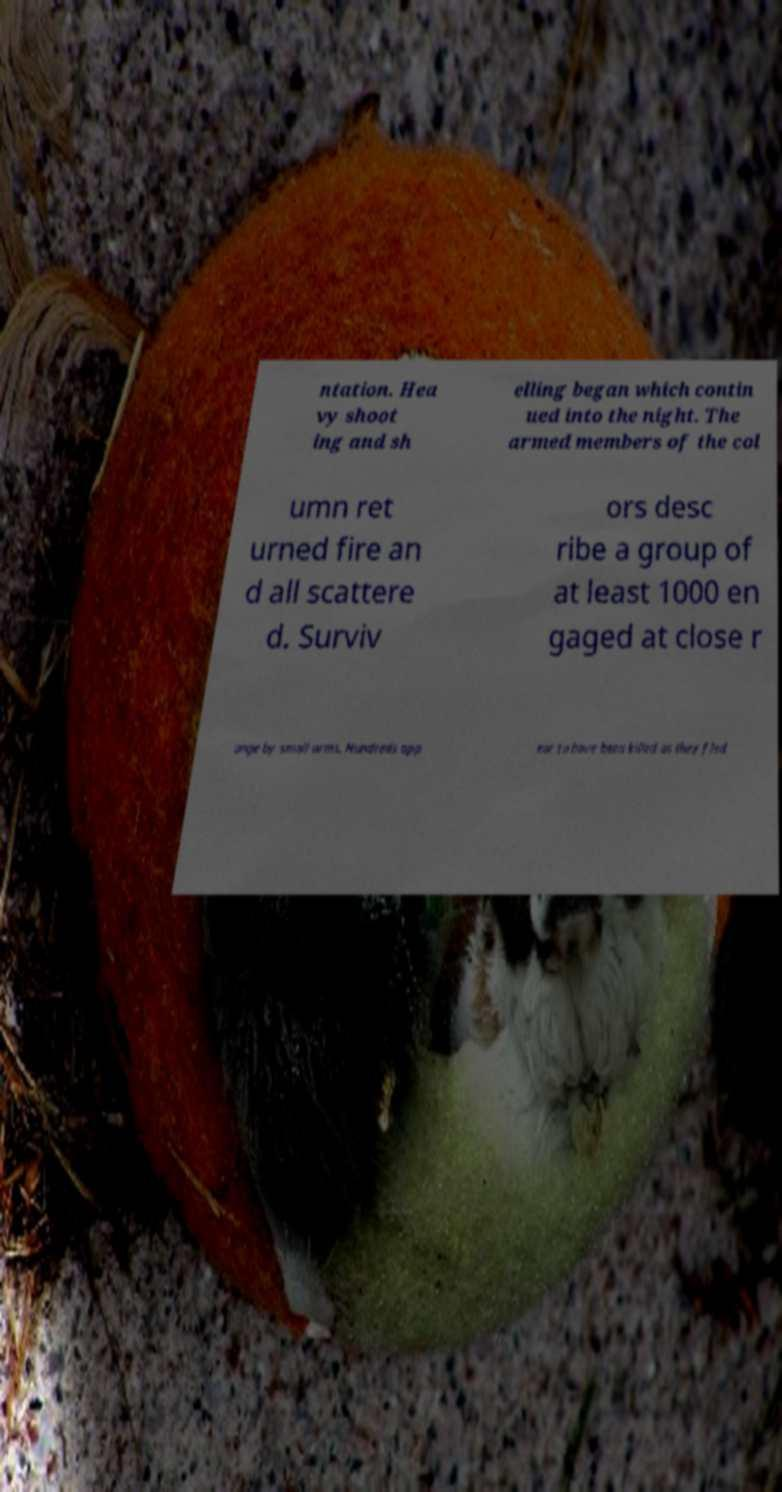For documentation purposes, I need the text within this image transcribed. Could you provide that? ntation. Hea vy shoot ing and sh elling began which contin ued into the night. The armed members of the col umn ret urned fire an d all scattere d. Surviv ors desc ribe a group of at least 1000 en gaged at close r ange by small arms. Hundreds app ear to have been killed as they fled 